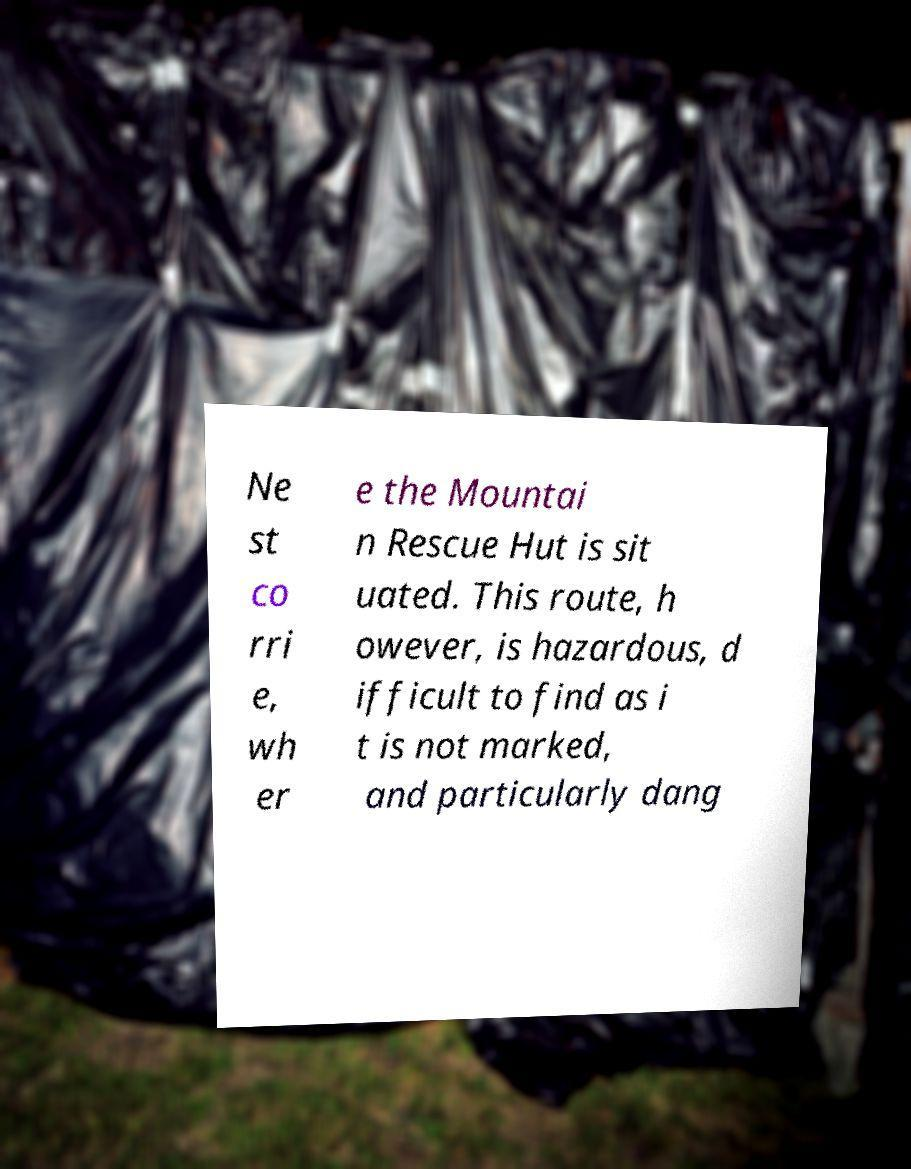Can you read and provide the text displayed in the image?This photo seems to have some interesting text. Can you extract and type it out for me? Ne st co rri e, wh er e the Mountai n Rescue Hut is sit uated. This route, h owever, is hazardous, d ifficult to find as i t is not marked, and particularly dang 